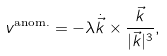<formula> <loc_0><loc_0><loc_500><loc_500>v ^ { \text {anom.} } = - \lambda \dot { \vec { k } } \times \frac { \vec { k } } { | \vec { k } | ^ { 3 } } ,</formula> 